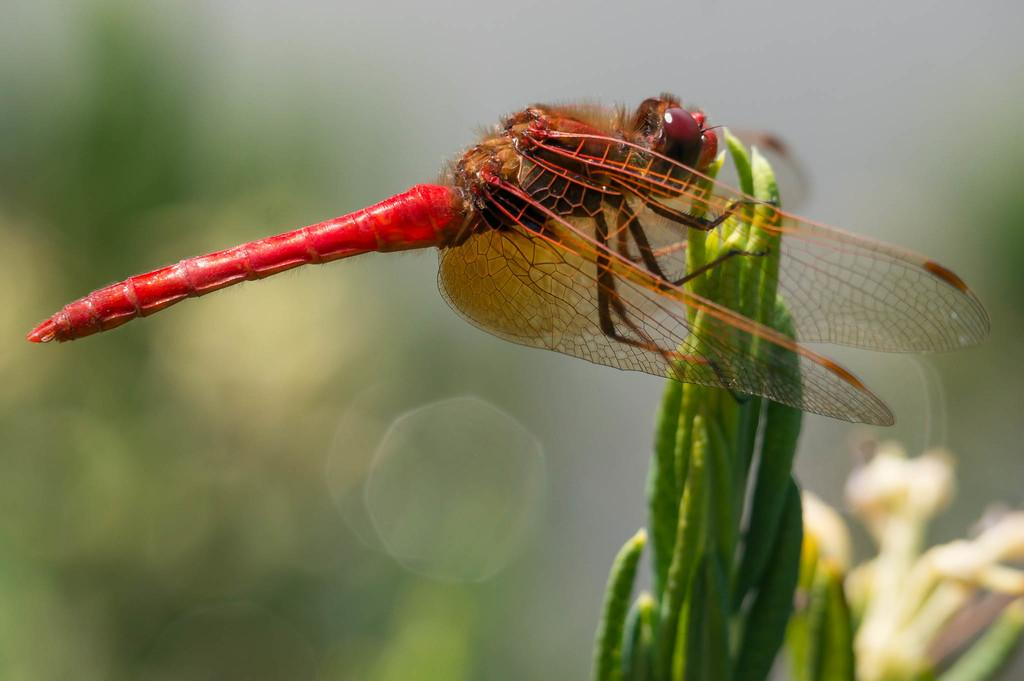What is present on the plant in the foreground of the image? There is a bee on a plant in the foreground of the image. What can be seen in the background of the image? There are plants visible in the background of the image. What type of pies are being sold in the image? There are no pies present in the image; it features a bee on a plant in the foreground and plants in the background. 